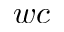<formula> <loc_0><loc_0><loc_500><loc_500>w c</formula> 